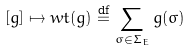Convert formula to latex. <formula><loc_0><loc_0><loc_500><loc_500>[ g ] \mapsto w t ( g ) \overset { \text {df} } { = } \sum _ { \sigma \in \Sigma _ { E } } g ( \sigma )</formula> 